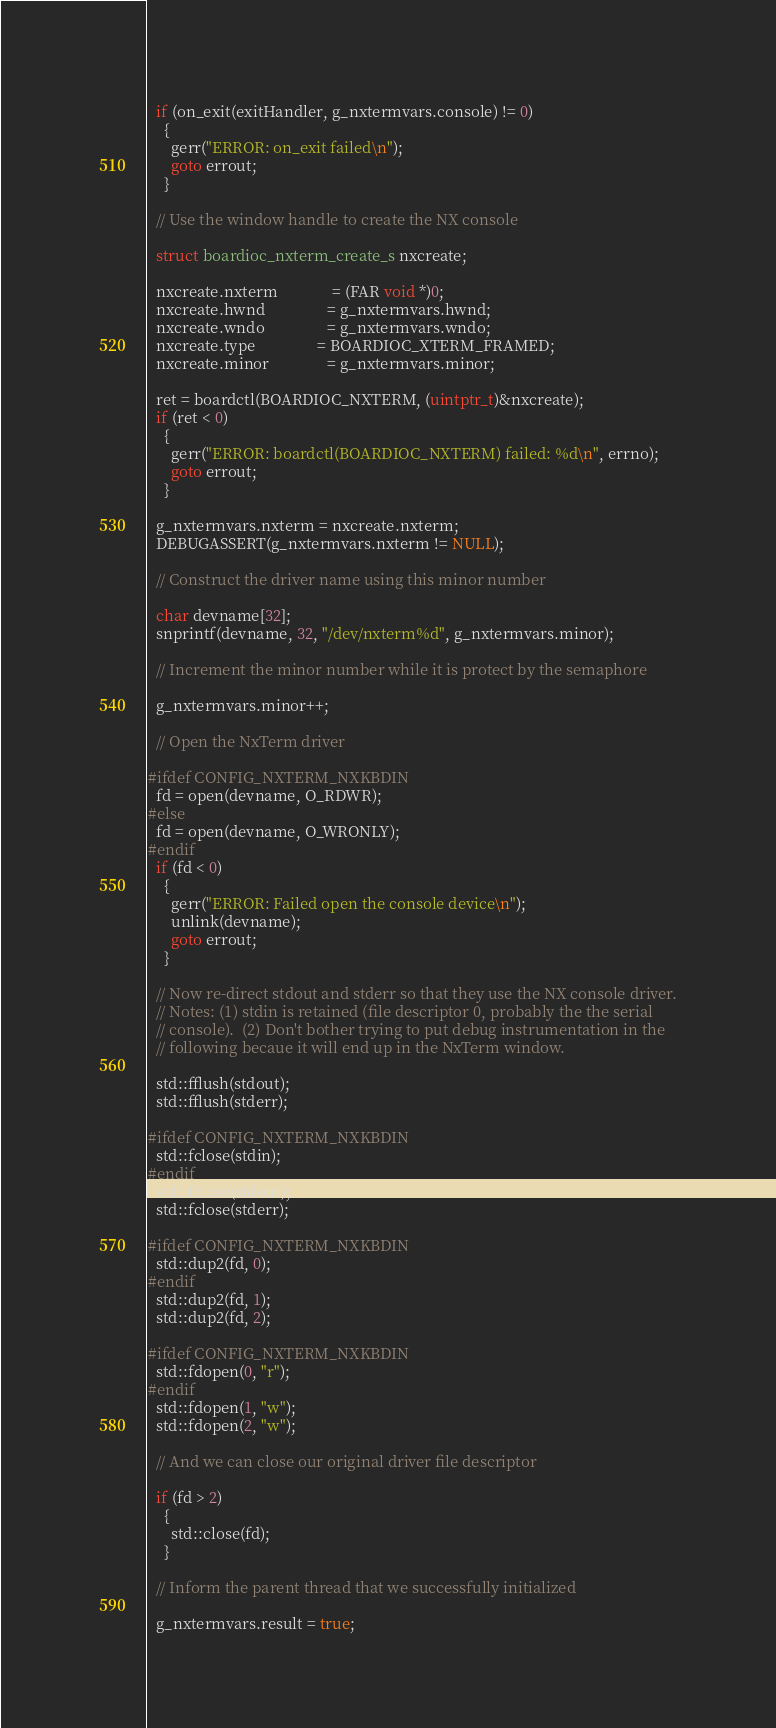<code> <loc_0><loc_0><loc_500><loc_500><_C++_>
  if (on_exit(exitHandler, g_nxtermvars.console) != 0)
    {
      gerr("ERROR: on_exit failed\n");
      goto errout;
    }

  // Use the window handle to create the NX console

  struct boardioc_nxterm_create_s nxcreate;

  nxcreate.nxterm              = (FAR void *)0;
  nxcreate.hwnd                = g_nxtermvars.hwnd;
  nxcreate.wndo                = g_nxtermvars.wndo;
  nxcreate.type                = BOARDIOC_XTERM_FRAMED;
  nxcreate.minor               = g_nxtermvars.minor;

  ret = boardctl(BOARDIOC_NXTERM, (uintptr_t)&nxcreate);
  if (ret < 0)
    {
      gerr("ERROR: boardctl(BOARDIOC_NXTERM) failed: %d\n", errno);
      goto errout;
    }

  g_nxtermvars.nxterm = nxcreate.nxterm;
  DEBUGASSERT(g_nxtermvars.nxterm != NULL);

  // Construct the driver name using this minor number

  char devname[32];
  snprintf(devname, 32, "/dev/nxterm%d", g_nxtermvars.minor);

  // Increment the minor number while it is protect by the semaphore

  g_nxtermvars.minor++;

  // Open the NxTerm driver

#ifdef CONFIG_NXTERM_NXKBDIN
  fd = open(devname, O_RDWR);
#else
  fd = open(devname, O_WRONLY);
#endif
  if (fd < 0)
    {
      gerr("ERROR: Failed open the console device\n");
      unlink(devname);
      goto errout;
    }

  // Now re-direct stdout and stderr so that they use the NX console driver.
  // Notes: (1) stdin is retained (file descriptor 0, probably the the serial
  // console).  (2) Don't bother trying to put debug instrumentation in the
  // following becaue it will end up in the NxTerm window.

  std::fflush(stdout);
  std::fflush(stderr);

#ifdef CONFIG_NXTERM_NXKBDIN
  std::fclose(stdin);
#endif
  std::fclose(stdout);
  std::fclose(stderr);

#ifdef CONFIG_NXTERM_NXKBDIN
  std::dup2(fd, 0);
#endif
  std::dup2(fd, 1);
  std::dup2(fd, 2);

#ifdef CONFIG_NXTERM_NXKBDIN
  std::fdopen(0, "r");
#endif
  std::fdopen(1, "w");
  std::fdopen(2, "w");

  // And we can close our original driver file descriptor

  if (fd > 2)
    {
      std::close(fd);
    }

  // Inform the parent thread that we successfully initialized

  g_nxtermvars.result = true;</code> 